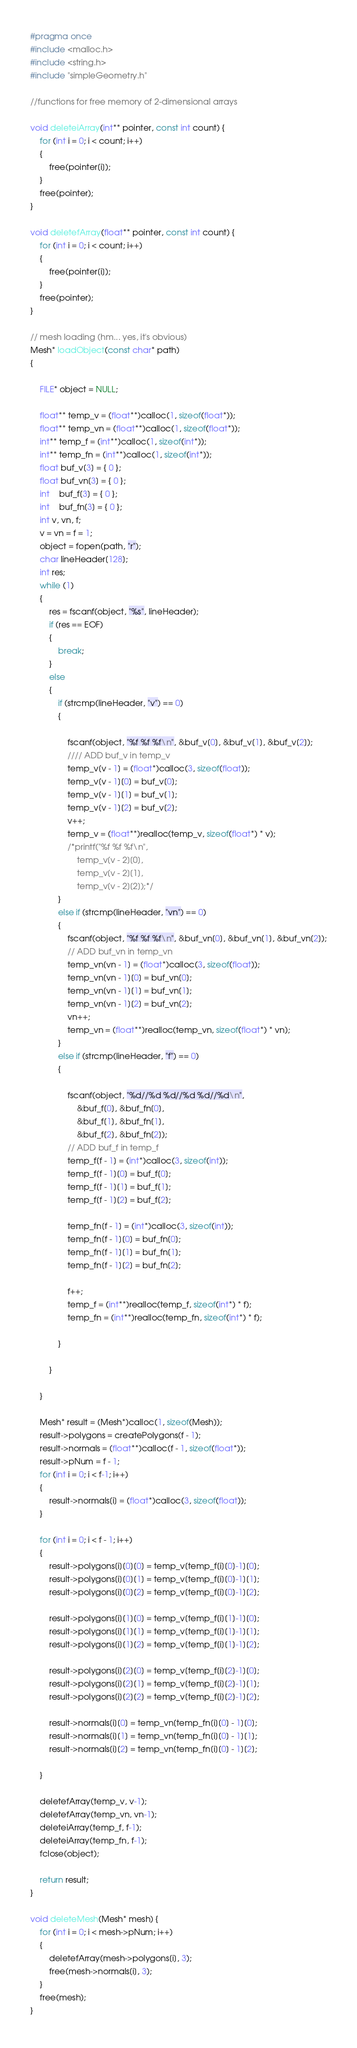Convert code to text. <code><loc_0><loc_0><loc_500><loc_500><_C_>#pragma once
#include <malloc.h>
#include <string.h>
#include "simpleGeometry.h"

//functions for free memory of 2-dimensional arrays

void deleteiArray(int** pointer, const int count) {
	for (int i = 0; i < count; i++)
	{
		free(pointer[i]);
	}
	free(pointer);
}

void deletefArray(float** pointer, const int count) {
	for (int i = 0; i < count; i++)
	{
		free(pointer[i]);
	}
	free(pointer);
}

// mesh loading (hm... yes, it's obvious)
Mesh* loadObject(const char* path)
{

	FILE* object = NULL;

	float** temp_v = (float**)calloc(1, sizeof(float*));
	float** temp_vn = (float**)calloc(1, sizeof(float*));
	int** temp_f = (int**)calloc(1, sizeof(int*));
	int** temp_fn = (int**)calloc(1, sizeof(int*));
	float buf_v[3] = { 0 };
	float buf_vn[3] = { 0 };
	int	buf_f[3] = { 0 };
	int	buf_fn[3] = { 0 };
	int v, vn, f;
	v = vn = f = 1;
	object = fopen(path, "r");
	char lineHeader[128];
	int res;
	while (1)
	{
		res = fscanf(object, "%s", lineHeader);
		if (res == EOF)
		{
			break;
		}
		else
		{
			if (strcmp(lineHeader, "v") == 0)
			{

				fscanf(object, "%f %f %f\n", &buf_v[0], &buf_v[1], &buf_v[2]);
				//// ADD buf_v in temp_v
				temp_v[v - 1] = (float*)calloc(3, sizeof(float));
				temp_v[v - 1][0] = buf_v[0];
				temp_v[v - 1][1] = buf_v[1];
				temp_v[v - 1][2] = buf_v[2];
				v++;
				temp_v = (float**)realloc(temp_v, sizeof(float*) * v);
				/*printf("%f %f %f\n",
					temp_v[v - 2][0],
					temp_v[v - 2][1], 
					temp_v[v - 2][2]);*/
			}
			else if (strcmp(lineHeader, "vn") == 0)
			{
				fscanf(object, "%f %f %f\n", &buf_vn[0], &buf_vn[1], &buf_vn[2]);
				// ADD buf_vn in temp_vn
				temp_vn[vn - 1] = (float*)calloc(3, sizeof(float));
				temp_vn[vn - 1][0] = buf_vn[0];
				temp_vn[vn - 1][1] = buf_vn[1];
				temp_vn[vn - 1][2] = buf_vn[2];
				vn++;
				temp_vn = (float**)realloc(temp_vn, sizeof(float*) * vn);
			}
			else if (strcmp(lineHeader, "f") == 0)
			{

				fscanf(object, "%d//%d %d//%d %d//%d\n",
					&buf_f[0], &buf_fn[0],
					&buf_f[1], &buf_fn[1],
					&buf_f[2], &buf_fn[2]);
				// ADD buf_f in temp_f
				temp_f[f - 1] = (int*)calloc(3, sizeof(int));
				temp_f[f - 1][0] = buf_f[0];
				temp_f[f - 1][1] = buf_f[1];
				temp_f[f - 1][2] = buf_f[2];

				temp_fn[f - 1] = (int*)calloc(3, sizeof(int));
				temp_fn[f - 1][0] = buf_fn[0];
				temp_fn[f - 1][1] = buf_fn[1];
				temp_fn[f - 1][2] = buf_fn[2];

				f++;
				temp_f = (int**)realloc(temp_f, sizeof(int*) * f);
				temp_fn = (int**)realloc(temp_fn, sizeof(int*) * f);

			}

		}

	}

	Mesh* result = (Mesh*)calloc(1, sizeof(Mesh));
	result->polygons = createPolygons(f - 1);
	result->normals = (float**)calloc(f - 1, sizeof(float*));
	result->pNum = f - 1;
	for (int i = 0; i < f-1; i++)
	{
		result->normals[i] = (float*)calloc(3, sizeof(float));
	}

	for (int i = 0; i < f - 1; i++)
	{
		result->polygons[i][0][0] = temp_v[temp_f[i][0]-1][0];
		result->polygons[i][0][1] = temp_v[temp_f[i][0]-1][1];
		result->polygons[i][0][2] = temp_v[temp_f[i][0]-1][2];
		
		result->polygons[i][1][0] = temp_v[temp_f[i][1]-1][0];
		result->polygons[i][1][1] = temp_v[temp_f[i][1]-1][1];
		result->polygons[i][1][2] = temp_v[temp_f[i][1]-1][2];
		
		result->polygons[i][2][0] = temp_v[temp_f[i][2]-1][0];
		result->polygons[i][2][1] = temp_v[temp_f[i][2]-1][1];
		result->polygons[i][2][2] = temp_v[temp_f[i][2]-1][2];

		result->normals[i][0] = temp_vn[temp_fn[i][0] - 1][0];
		result->normals[i][1] = temp_vn[temp_fn[i][0] - 1][1];
		result->normals[i][2] = temp_vn[temp_fn[i][0] - 1][2];

	}
	
	deletefArray(temp_v, v-1);
	deletefArray(temp_vn, vn-1);
	deleteiArray(temp_f, f-1);
	deleteiArray(temp_fn, f-1);
	fclose(object);

	return result;
}

void deleteMesh(Mesh* mesh) {
	for (int i = 0; i < mesh->pNum; i++)
	{
		deletefArray(mesh->polygons[i], 3);
		free(mesh->normals[i], 3);
	}
	free(mesh);
}
</code> 